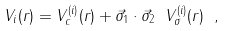Convert formula to latex. <formula><loc_0><loc_0><loc_500><loc_500>V _ { i } ( r ) = V ^ { ( i ) } _ { c } ( r ) + \vec { \sigma } _ { 1 } \cdot \vec { \sigma } _ { 2 } \ V ^ { ( i ) } _ { \sigma } ( r ) \ ,</formula> 